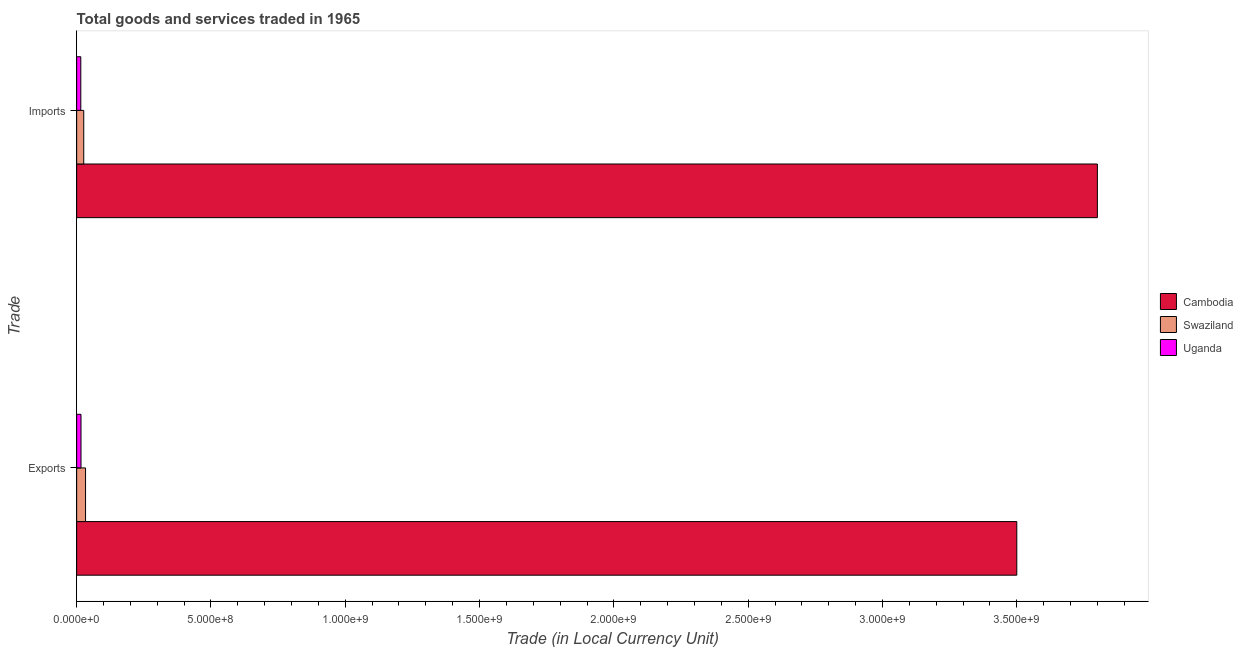How many different coloured bars are there?
Your answer should be compact. 3. How many groups of bars are there?
Provide a succinct answer. 2. How many bars are there on the 1st tick from the bottom?
Keep it short and to the point. 3. What is the label of the 2nd group of bars from the top?
Give a very brief answer. Exports. What is the imports of goods and services in Cambodia?
Offer a terse response. 3.80e+09. Across all countries, what is the maximum export of goods and services?
Offer a terse response. 3.50e+09. Across all countries, what is the minimum export of goods and services?
Provide a succinct answer. 1.62e+07. In which country was the imports of goods and services maximum?
Offer a very short reply. Cambodia. In which country was the imports of goods and services minimum?
Your response must be concise. Uganda. What is the total imports of goods and services in the graph?
Keep it short and to the point. 3.84e+09. What is the difference between the export of goods and services in Cambodia and that in Swaziland?
Your response must be concise. 3.47e+09. What is the difference between the imports of goods and services in Uganda and the export of goods and services in Swaziland?
Make the answer very short. -1.77e+07. What is the average export of goods and services per country?
Your answer should be compact. 1.18e+09. What is the difference between the export of goods and services and imports of goods and services in Swaziland?
Make the answer very short. 6.70e+06. What is the ratio of the export of goods and services in Cambodia to that in Uganda?
Give a very brief answer. 216.58. Is the imports of goods and services in Cambodia less than that in Uganda?
Provide a short and direct response. No. In how many countries, is the export of goods and services greater than the average export of goods and services taken over all countries?
Keep it short and to the point. 1. What does the 1st bar from the top in Exports represents?
Offer a very short reply. Uganda. What does the 1st bar from the bottom in Exports represents?
Provide a short and direct response. Cambodia. How many bars are there?
Keep it short and to the point. 6. How many countries are there in the graph?
Your response must be concise. 3. Does the graph contain any zero values?
Your response must be concise. No. Does the graph contain grids?
Your response must be concise. No. Where does the legend appear in the graph?
Provide a succinct answer. Center right. How many legend labels are there?
Your answer should be compact. 3. How are the legend labels stacked?
Offer a very short reply. Vertical. What is the title of the graph?
Offer a terse response. Total goods and services traded in 1965. Does "West Bank and Gaza" appear as one of the legend labels in the graph?
Offer a very short reply. No. What is the label or title of the X-axis?
Ensure brevity in your answer.  Trade (in Local Currency Unit). What is the label or title of the Y-axis?
Your answer should be very brief. Trade. What is the Trade (in Local Currency Unit) in Cambodia in Exports?
Your answer should be very brief. 3.50e+09. What is the Trade (in Local Currency Unit) in Swaziland in Exports?
Keep it short and to the point. 3.31e+07. What is the Trade (in Local Currency Unit) of Uganda in Exports?
Keep it short and to the point. 1.62e+07. What is the Trade (in Local Currency Unit) in Cambodia in Imports?
Your answer should be very brief. 3.80e+09. What is the Trade (in Local Currency Unit) in Swaziland in Imports?
Offer a very short reply. 2.64e+07. What is the Trade (in Local Currency Unit) in Uganda in Imports?
Provide a succinct answer. 1.54e+07. Across all Trade, what is the maximum Trade (in Local Currency Unit) of Cambodia?
Give a very brief answer. 3.80e+09. Across all Trade, what is the maximum Trade (in Local Currency Unit) in Swaziland?
Offer a very short reply. 3.31e+07. Across all Trade, what is the maximum Trade (in Local Currency Unit) of Uganda?
Your response must be concise. 1.62e+07. Across all Trade, what is the minimum Trade (in Local Currency Unit) of Cambodia?
Your answer should be compact. 3.50e+09. Across all Trade, what is the minimum Trade (in Local Currency Unit) of Swaziland?
Your answer should be very brief. 2.64e+07. Across all Trade, what is the minimum Trade (in Local Currency Unit) of Uganda?
Make the answer very short. 1.54e+07. What is the total Trade (in Local Currency Unit) in Cambodia in the graph?
Provide a short and direct response. 7.30e+09. What is the total Trade (in Local Currency Unit) of Swaziland in the graph?
Keep it short and to the point. 5.95e+07. What is the total Trade (in Local Currency Unit) in Uganda in the graph?
Keep it short and to the point. 3.16e+07. What is the difference between the Trade (in Local Currency Unit) of Cambodia in Exports and that in Imports?
Your answer should be compact. -3.00e+08. What is the difference between the Trade (in Local Currency Unit) of Swaziland in Exports and that in Imports?
Your answer should be compact. 6.70e+06. What is the difference between the Trade (in Local Currency Unit) of Uganda in Exports and that in Imports?
Offer a terse response. 7.70e+05. What is the difference between the Trade (in Local Currency Unit) in Cambodia in Exports and the Trade (in Local Currency Unit) in Swaziland in Imports?
Your answer should be compact. 3.47e+09. What is the difference between the Trade (in Local Currency Unit) in Cambodia in Exports and the Trade (in Local Currency Unit) in Uganda in Imports?
Ensure brevity in your answer.  3.48e+09. What is the difference between the Trade (in Local Currency Unit) in Swaziland in Exports and the Trade (in Local Currency Unit) in Uganda in Imports?
Make the answer very short. 1.77e+07. What is the average Trade (in Local Currency Unit) of Cambodia per Trade?
Ensure brevity in your answer.  3.65e+09. What is the average Trade (in Local Currency Unit) in Swaziland per Trade?
Your answer should be very brief. 2.98e+07. What is the average Trade (in Local Currency Unit) in Uganda per Trade?
Keep it short and to the point. 1.58e+07. What is the difference between the Trade (in Local Currency Unit) in Cambodia and Trade (in Local Currency Unit) in Swaziland in Exports?
Ensure brevity in your answer.  3.47e+09. What is the difference between the Trade (in Local Currency Unit) of Cambodia and Trade (in Local Currency Unit) of Uganda in Exports?
Keep it short and to the point. 3.48e+09. What is the difference between the Trade (in Local Currency Unit) of Swaziland and Trade (in Local Currency Unit) of Uganda in Exports?
Offer a terse response. 1.69e+07. What is the difference between the Trade (in Local Currency Unit) in Cambodia and Trade (in Local Currency Unit) in Swaziland in Imports?
Give a very brief answer. 3.77e+09. What is the difference between the Trade (in Local Currency Unit) in Cambodia and Trade (in Local Currency Unit) in Uganda in Imports?
Your response must be concise. 3.78e+09. What is the difference between the Trade (in Local Currency Unit) of Swaziland and Trade (in Local Currency Unit) of Uganda in Imports?
Offer a very short reply. 1.10e+07. What is the ratio of the Trade (in Local Currency Unit) of Cambodia in Exports to that in Imports?
Make the answer very short. 0.92. What is the ratio of the Trade (in Local Currency Unit) of Swaziland in Exports to that in Imports?
Your answer should be very brief. 1.25. What is the difference between the highest and the second highest Trade (in Local Currency Unit) of Cambodia?
Give a very brief answer. 3.00e+08. What is the difference between the highest and the second highest Trade (in Local Currency Unit) of Swaziland?
Make the answer very short. 6.70e+06. What is the difference between the highest and the second highest Trade (in Local Currency Unit) of Uganda?
Your answer should be compact. 7.70e+05. What is the difference between the highest and the lowest Trade (in Local Currency Unit) in Cambodia?
Your response must be concise. 3.00e+08. What is the difference between the highest and the lowest Trade (in Local Currency Unit) in Swaziland?
Your answer should be compact. 6.70e+06. What is the difference between the highest and the lowest Trade (in Local Currency Unit) in Uganda?
Keep it short and to the point. 7.70e+05. 